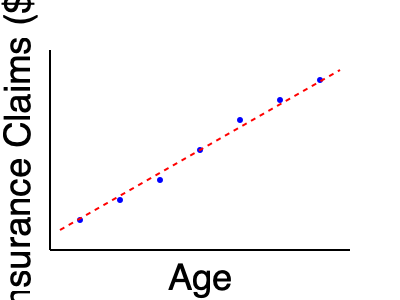Based on the scatter plot showing the relationship between age and insurance claims, what can be inferred about the correlation between these two variables? To interpret the scatter plot and determine the correlation between age and insurance claims, we need to follow these steps:

1. Observe the overall pattern of the data points:
   The points seem to form a clear trend from the upper-left to the lower-right of the graph.

2. Identify the direction of the relationship:
   As age increases (moving right on the x-axis), the insurance claims amount decreases (moving down on the y-axis).

3. Assess the strength of the relationship:
   The points are relatively close to the trend line (red dashed line), indicating a strong relationship.

4. Determine the type of correlation:
   Since the variables move in opposite directions (one increases while the other decreases), this is a negative or inverse correlation.

5. Evaluate the linearity:
   The points appear to follow a roughly straight line, suggesting a linear relationship.

6. Consider the correlation strength:
   Given the clear pattern and proximity of points to the trend line, this appears to be a strong negative correlation.

Based on these observations, we can conclude that there is a strong negative linear correlation between age and insurance claims. This suggests that as individuals get older, they tend to make fewer or less expensive insurance claims.
Answer: Strong negative linear correlation 